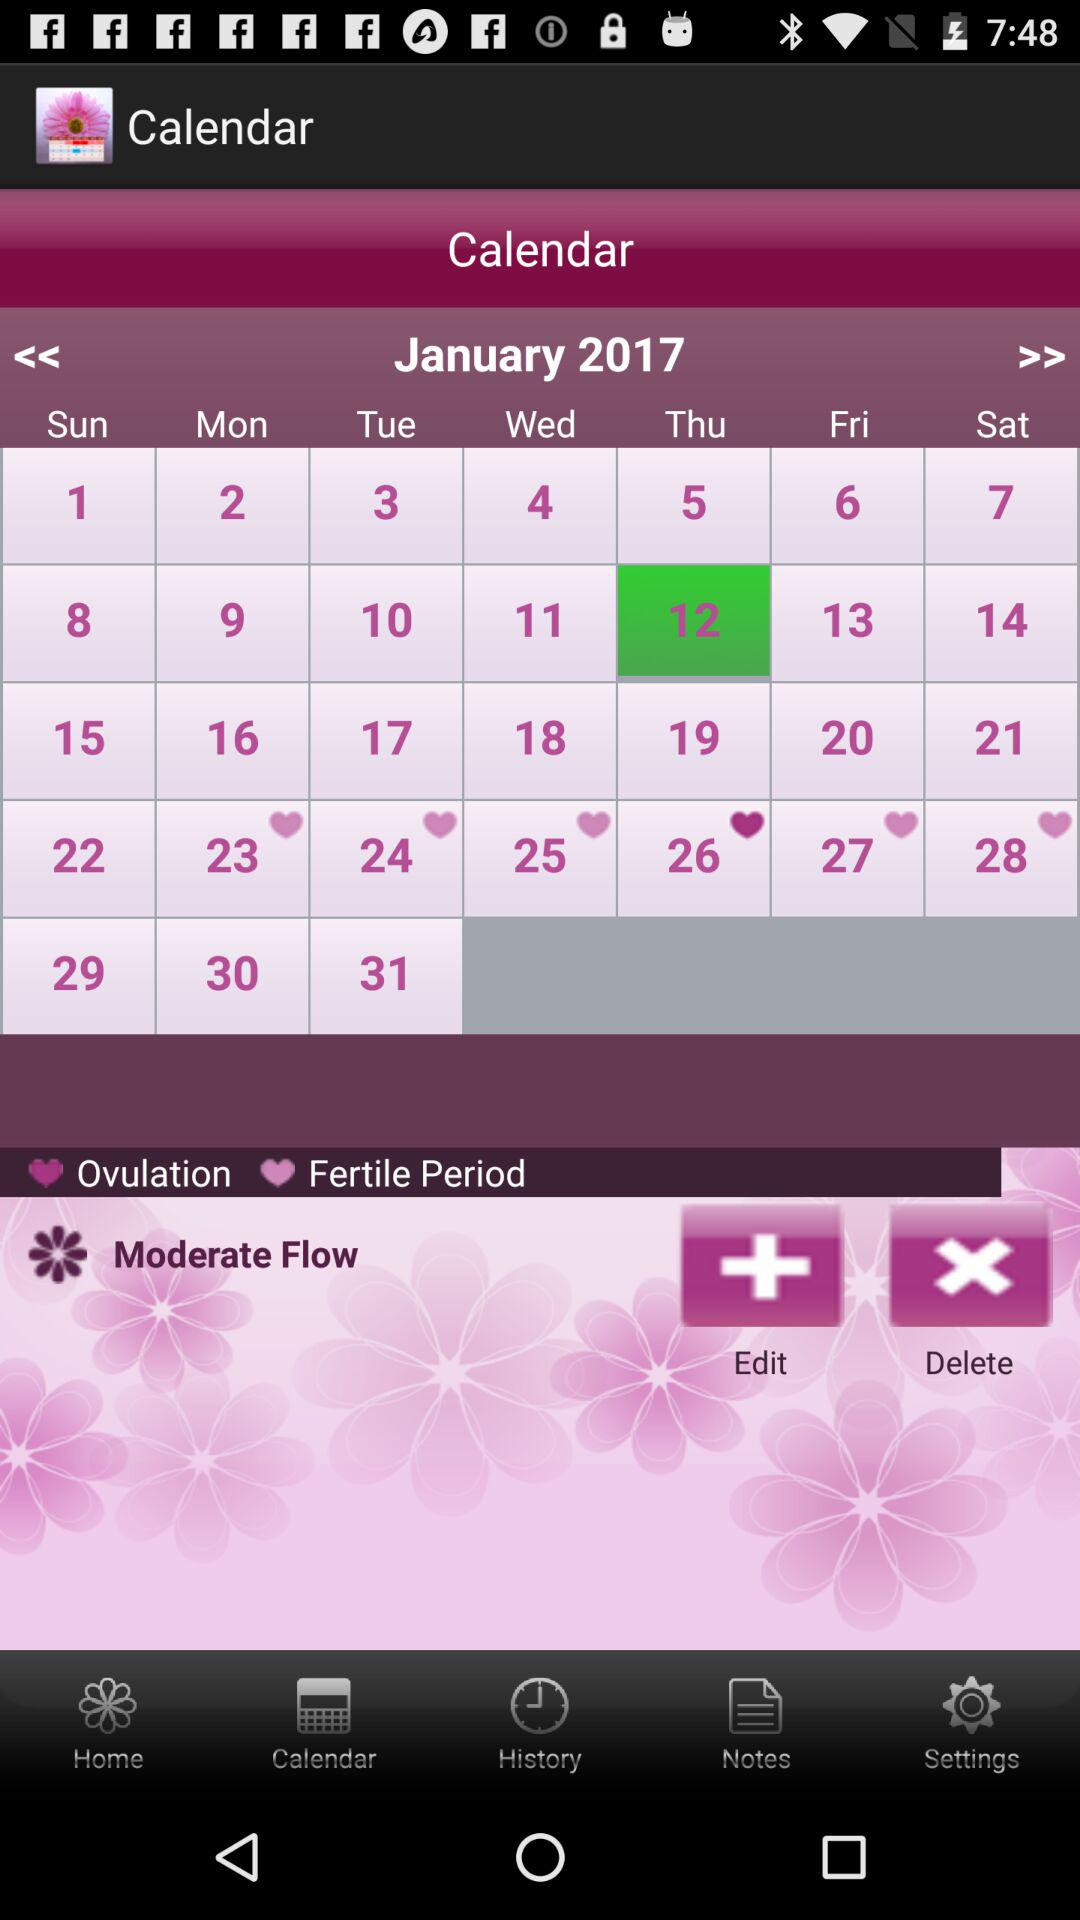What are the dates highlighted for the fertile period? The highlighted dates are Monday, January 23, 2017; Tuesday, January 24, 2017; Wednesday, January 25, 2017; Friday, January 27, 2017 and Saturday, January 28, 2017. 